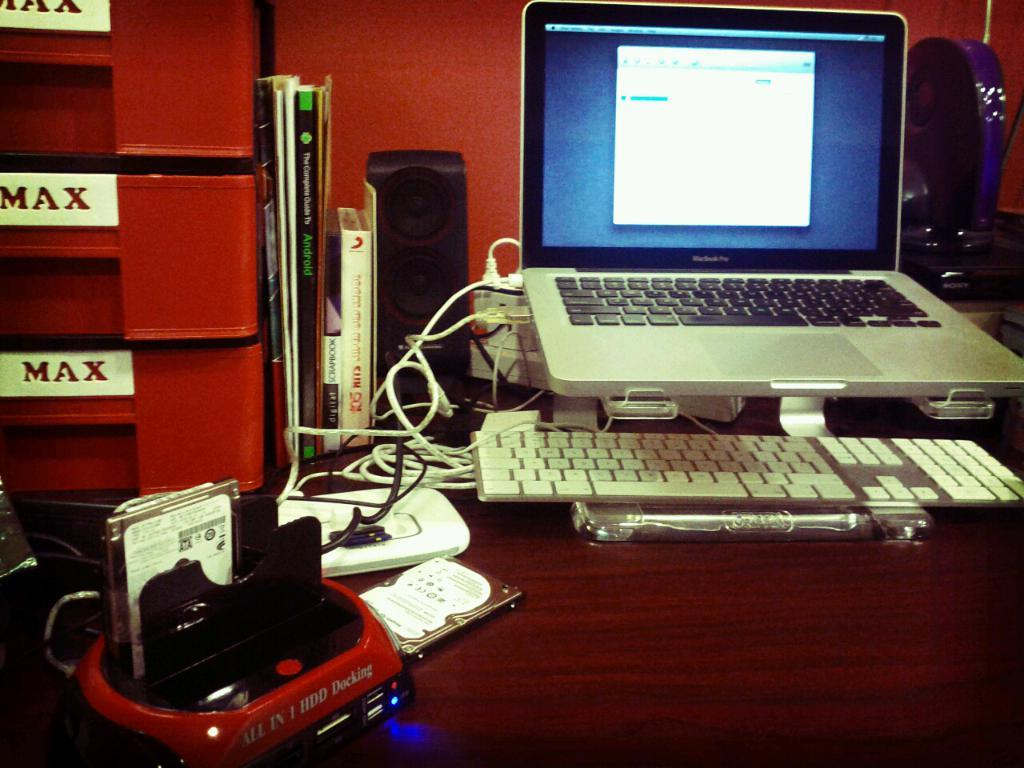What objects related to learning or work can be seen in the image? There are books, a keyboard, and a laptop in the image. Can you describe the type of device used for typing in the image? There is a keyboard in the image. What electronic device is also present in the image? There is a laptop in the image. How many dinosaurs are playing the drum in the image? There are no dinosaurs or drums present in the image. 